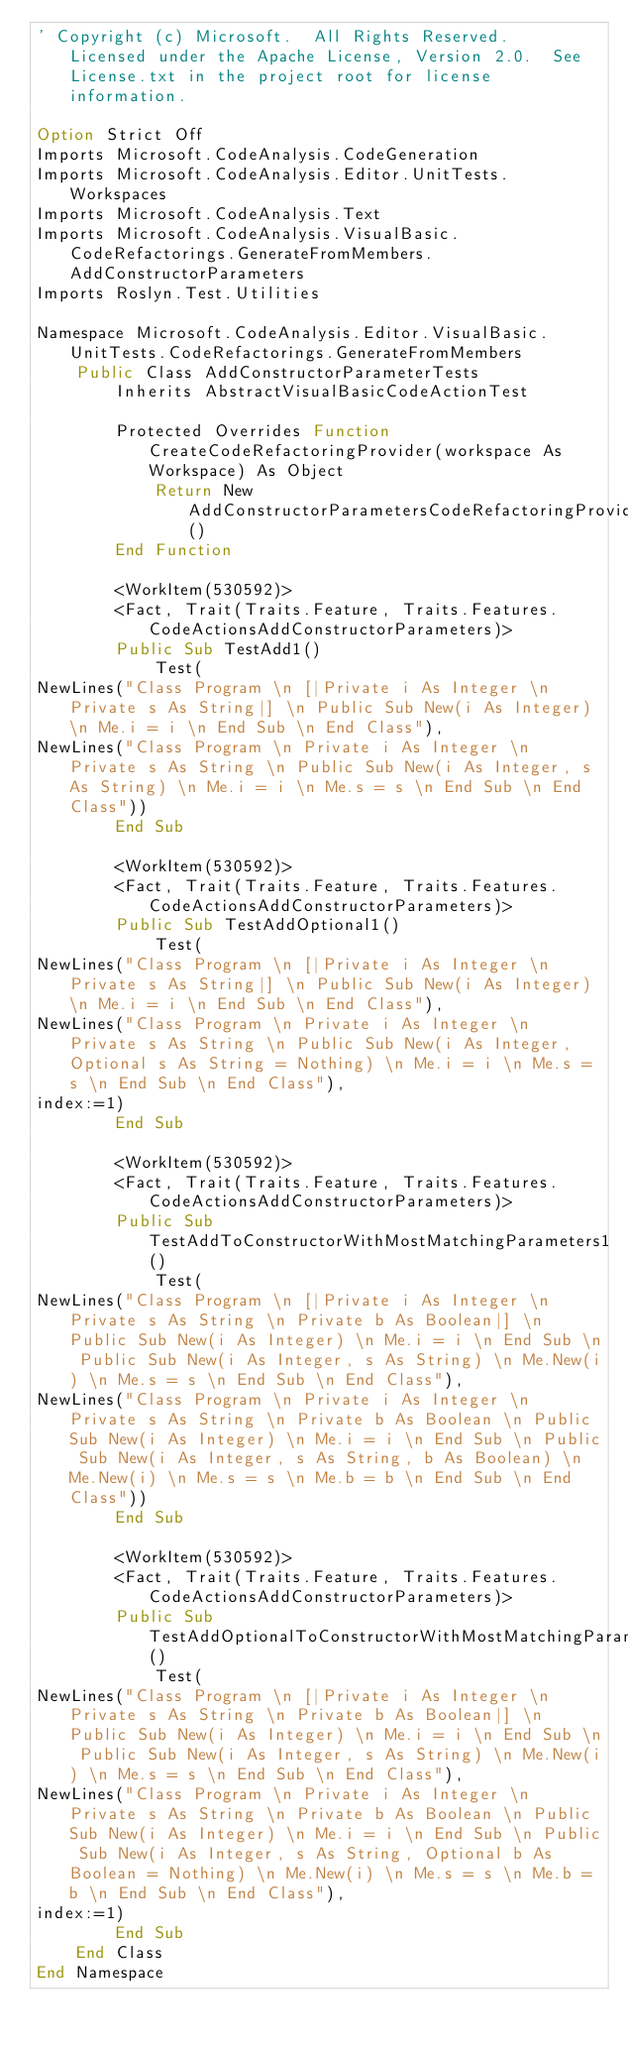Convert code to text. <code><loc_0><loc_0><loc_500><loc_500><_VisualBasic_>' Copyright (c) Microsoft.  All Rights Reserved.  Licensed under the Apache License, Version 2.0.  See License.txt in the project root for license information.

Option Strict Off
Imports Microsoft.CodeAnalysis.CodeGeneration
Imports Microsoft.CodeAnalysis.Editor.UnitTests.Workspaces
Imports Microsoft.CodeAnalysis.Text
Imports Microsoft.CodeAnalysis.VisualBasic.CodeRefactorings.GenerateFromMembers.AddConstructorParameters
Imports Roslyn.Test.Utilities

Namespace Microsoft.CodeAnalysis.Editor.VisualBasic.UnitTests.CodeRefactorings.GenerateFromMembers
    Public Class AddConstructorParameterTests
        Inherits AbstractVisualBasicCodeActionTest

        Protected Overrides Function CreateCodeRefactoringProvider(workspace As Workspace) As Object
            Return New AddConstructorParametersCodeRefactoringProvider()
        End Function

        <WorkItem(530592)>
        <Fact, Trait(Traits.Feature, Traits.Features.CodeActionsAddConstructorParameters)>
        Public Sub TestAdd1()
            Test(
NewLines("Class Program \n [|Private i As Integer \n Private s As String|] \n Public Sub New(i As Integer) \n Me.i = i \n End Sub \n End Class"),
NewLines("Class Program \n Private i As Integer \n Private s As String \n Public Sub New(i As Integer, s As String) \n Me.i = i \n Me.s = s \n End Sub \n End Class"))
        End Sub

        <WorkItem(530592)>
        <Fact, Trait(Traits.Feature, Traits.Features.CodeActionsAddConstructorParameters)>
        Public Sub TestAddOptional1()
            Test(
NewLines("Class Program \n [|Private i As Integer \n Private s As String|] \n Public Sub New(i As Integer) \n Me.i = i \n End Sub \n End Class"),
NewLines("Class Program \n Private i As Integer \n Private s As String \n Public Sub New(i As Integer, Optional s As String = Nothing) \n Me.i = i \n Me.s = s \n End Sub \n End Class"),
index:=1)
        End Sub

        <WorkItem(530592)>
        <Fact, Trait(Traits.Feature, Traits.Features.CodeActionsAddConstructorParameters)>
        Public Sub TestAddToConstructorWithMostMatchingParameters1()
            Test(
NewLines("Class Program \n [|Private i As Integer \n Private s As String \n Private b As Boolean|] \n Public Sub New(i As Integer) \n Me.i = i \n End Sub \n Public Sub New(i As Integer, s As String) \n Me.New(i) \n Me.s = s \n End Sub \n End Class"),
NewLines("Class Program \n Private i As Integer \n Private s As String \n Private b As Boolean \n Public Sub New(i As Integer) \n Me.i = i \n End Sub \n Public Sub New(i As Integer, s As String, b As Boolean) \n Me.New(i) \n Me.s = s \n Me.b = b \n End Sub \n End Class"))
        End Sub

        <WorkItem(530592)>
        <Fact, Trait(Traits.Feature, Traits.Features.CodeActionsAddConstructorParameters)>
        Public Sub TestAddOptionalToConstructorWithMostMatchingParameters1()
            Test(
NewLines("Class Program \n [|Private i As Integer \n Private s As String \n Private b As Boolean|] \n Public Sub New(i As Integer) \n Me.i = i \n End Sub \n Public Sub New(i As Integer, s As String) \n Me.New(i) \n Me.s = s \n End Sub \n End Class"),
NewLines("Class Program \n Private i As Integer \n Private s As String \n Private b As Boolean \n Public Sub New(i As Integer) \n Me.i = i \n End Sub \n Public Sub New(i As Integer, s As String, Optional b As Boolean = Nothing) \n Me.New(i) \n Me.s = s \n Me.b = b \n End Sub \n End Class"),
index:=1)
        End Sub
    End Class
End Namespace
</code> 